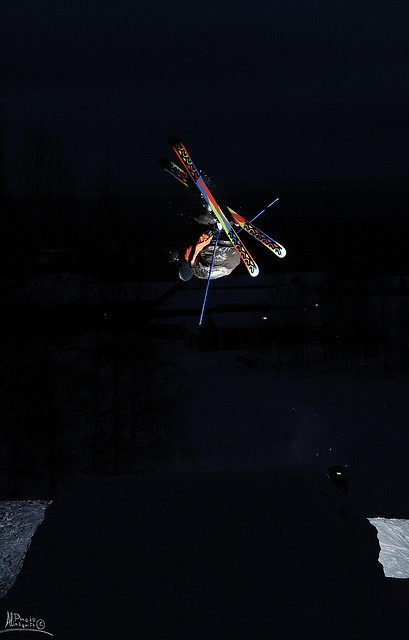Describe the objects in this image and their specific colors. I can see skis in black, blue, brown, and maroon tones and people in black, gray, darkgray, and lightgray tones in this image. 